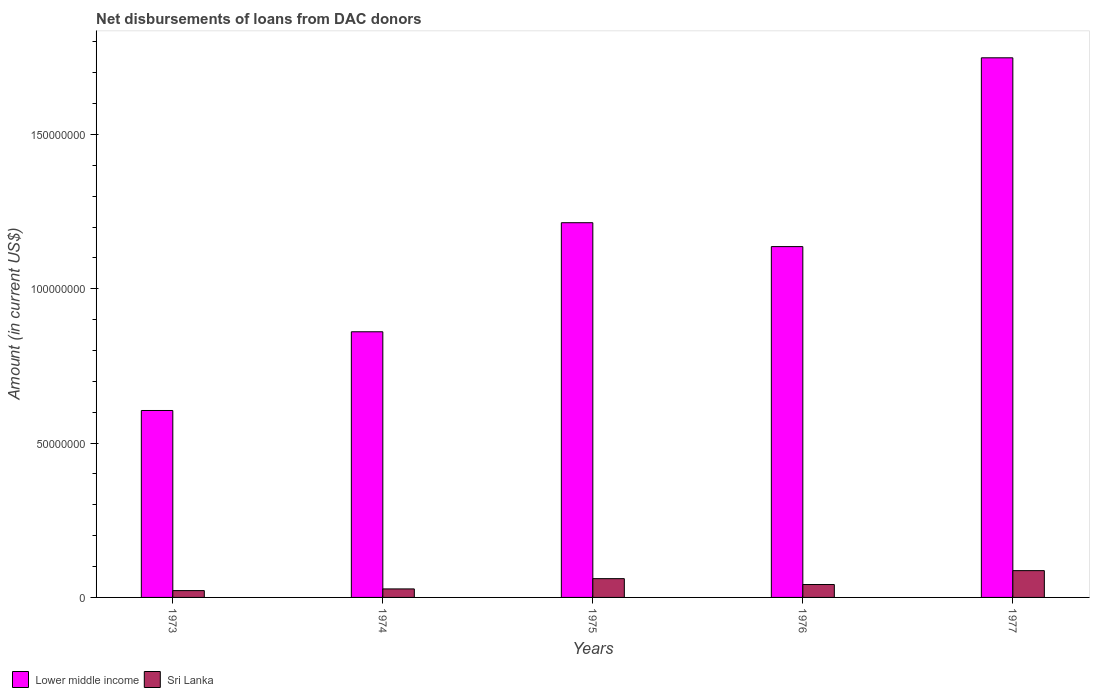Are the number of bars on each tick of the X-axis equal?
Give a very brief answer. Yes. How many bars are there on the 5th tick from the left?
Provide a short and direct response. 2. How many bars are there on the 1st tick from the right?
Make the answer very short. 2. What is the label of the 2nd group of bars from the left?
Ensure brevity in your answer.  1974. In how many cases, is the number of bars for a given year not equal to the number of legend labels?
Your response must be concise. 0. What is the amount of loans disbursed in Lower middle income in 1973?
Provide a short and direct response. 6.06e+07. Across all years, what is the maximum amount of loans disbursed in Lower middle income?
Your response must be concise. 1.75e+08. Across all years, what is the minimum amount of loans disbursed in Sri Lanka?
Provide a short and direct response. 2.21e+06. In which year was the amount of loans disbursed in Lower middle income maximum?
Provide a short and direct response. 1977. In which year was the amount of loans disbursed in Sri Lanka minimum?
Provide a short and direct response. 1973. What is the total amount of loans disbursed in Sri Lanka in the graph?
Offer a very short reply. 2.39e+07. What is the difference between the amount of loans disbursed in Lower middle income in 1976 and that in 1977?
Ensure brevity in your answer.  -6.12e+07. What is the difference between the amount of loans disbursed in Lower middle income in 1977 and the amount of loans disbursed in Sri Lanka in 1976?
Ensure brevity in your answer.  1.71e+08. What is the average amount of loans disbursed in Sri Lanka per year?
Provide a short and direct response. 4.78e+06. In the year 1974, what is the difference between the amount of loans disbursed in Lower middle income and amount of loans disbursed in Sri Lanka?
Your answer should be compact. 8.33e+07. What is the ratio of the amount of loans disbursed in Sri Lanka in 1973 to that in 1976?
Your response must be concise. 0.53. What is the difference between the highest and the second highest amount of loans disbursed in Lower middle income?
Offer a very short reply. 5.34e+07. What is the difference between the highest and the lowest amount of loans disbursed in Sri Lanka?
Your response must be concise. 6.47e+06. Is the sum of the amount of loans disbursed in Lower middle income in 1974 and 1975 greater than the maximum amount of loans disbursed in Sri Lanka across all years?
Keep it short and to the point. Yes. What does the 2nd bar from the left in 1975 represents?
Provide a succinct answer. Sri Lanka. What does the 1st bar from the right in 1977 represents?
Your answer should be compact. Sri Lanka. How many bars are there?
Make the answer very short. 10. How many years are there in the graph?
Offer a very short reply. 5. Does the graph contain grids?
Provide a short and direct response. No. Where does the legend appear in the graph?
Provide a short and direct response. Bottom left. How many legend labels are there?
Your response must be concise. 2. What is the title of the graph?
Your answer should be compact. Net disbursements of loans from DAC donors. What is the label or title of the X-axis?
Your response must be concise. Years. What is the Amount (in current US$) of Lower middle income in 1973?
Your answer should be compact. 6.06e+07. What is the Amount (in current US$) of Sri Lanka in 1973?
Provide a succinct answer. 2.21e+06. What is the Amount (in current US$) of Lower middle income in 1974?
Provide a short and direct response. 8.61e+07. What is the Amount (in current US$) in Sri Lanka in 1974?
Make the answer very short. 2.76e+06. What is the Amount (in current US$) in Lower middle income in 1975?
Keep it short and to the point. 1.21e+08. What is the Amount (in current US$) of Sri Lanka in 1975?
Provide a succinct answer. 6.08e+06. What is the Amount (in current US$) in Lower middle income in 1976?
Ensure brevity in your answer.  1.14e+08. What is the Amount (in current US$) of Sri Lanka in 1976?
Your answer should be very brief. 4.18e+06. What is the Amount (in current US$) in Lower middle income in 1977?
Offer a very short reply. 1.75e+08. What is the Amount (in current US$) in Sri Lanka in 1977?
Make the answer very short. 8.68e+06. Across all years, what is the maximum Amount (in current US$) of Lower middle income?
Give a very brief answer. 1.75e+08. Across all years, what is the maximum Amount (in current US$) in Sri Lanka?
Keep it short and to the point. 8.68e+06. Across all years, what is the minimum Amount (in current US$) of Lower middle income?
Ensure brevity in your answer.  6.06e+07. Across all years, what is the minimum Amount (in current US$) of Sri Lanka?
Provide a succinct answer. 2.21e+06. What is the total Amount (in current US$) of Lower middle income in the graph?
Your response must be concise. 5.56e+08. What is the total Amount (in current US$) in Sri Lanka in the graph?
Make the answer very short. 2.39e+07. What is the difference between the Amount (in current US$) in Lower middle income in 1973 and that in 1974?
Make the answer very short. -2.55e+07. What is the difference between the Amount (in current US$) in Sri Lanka in 1973 and that in 1974?
Keep it short and to the point. -5.48e+05. What is the difference between the Amount (in current US$) in Lower middle income in 1973 and that in 1975?
Your response must be concise. -6.08e+07. What is the difference between the Amount (in current US$) in Sri Lanka in 1973 and that in 1975?
Ensure brevity in your answer.  -3.87e+06. What is the difference between the Amount (in current US$) of Lower middle income in 1973 and that in 1976?
Ensure brevity in your answer.  -5.31e+07. What is the difference between the Amount (in current US$) in Sri Lanka in 1973 and that in 1976?
Ensure brevity in your answer.  -1.97e+06. What is the difference between the Amount (in current US$) of Lower middle income in 1973 and that in 1977?
Make the answer very short. -1.14e+08. What is the difference between the Amount (in current US$) of Sri Lanka in 1973 and that in 1977?
Your answer should be very brief. -6.47e+06. What is the difference between the Amount (in current US$) of Lower middle income in 1974 and that in 1975?
Offer a very short reply. -3.53e+07. What is the difference between the Amount (in current US$) in Sri Lanka in 1974 and that in 1975?
Make the answer very short. -3.32e+06. What is the difference between the Amount (in current US$) of Lower middle income in 1974 and that in 1976?
Provide a short and direct response. -2.76e+07. What is the difference between the Amount (in current US$) of Sri Lanka in 1974 and that in 1976?
Your answer should be compact. -1.42e+06. What is the difference between the Amount (in current US$) of Lower middle income in 1974 and that in 1977?
Your answer should be compact. -8.88e+07. What is the difference between the Amount (in current US$) of Sri Lanka in 1974 and that in 1977?
Make the answer very short. -5.92e+06. What is the difference between the Amount (in current US$) of Lower middle income in 1975 and that in 1976?
Your answer should be compact. 7.74e+06. What is the difference between the Amount (in current US$) in Sri Lanka in 1975 and that in 1976?
Provide a short and direct response. 1.90e+06. What is the difference between the Amount (in current US$) of Lower middle income in 1975 and that in 1977?
Offer a terse response. -5.34e+07. What is the difference between the Amount (in current US$) of Sri Lanka in 1975 and that in 1977?
Make the answer very short. -2.60e+06. What is the difference between the Amount (in current US$) in Lower middle income in 1976 and that in 1977?
Ensure brevity in your answer.  -6.12e+07. What is the difference between the Amount (in current US$) in Sri Lanka in 1976 and that in 1977?
Your response must be concise. -4.50e+06. What is the difference between the Amount (in current US$) of Lower middle income in 1973 and the Amount (in current US$) of Sri Lanka in 1974?
Provide a short and direct response. 5.78e+07. What is the difference between the Amount (in current US$) of Lower middle income in 1973 and the Amount (in current US$) of Sri Lanka in 1975?
Your answer should be very brief. 5.45e+07. What is the difference between the Amount (in current US$) of Lower middle income in 1973 and the Amount (in current US$) of Sri Lanka in 1976?
Make the answer very short. 5.64e+07. What is the difference between the Amount (in current US$) of Lower middle income in 1973 and the Amount (in current US$) of Sri Lanka in 1977?
Offer a terse response. 5.19e+07. What is the difference between the Amount (in current US$) of Lower middle income in 1974 and the Amount (in current US$) of Sri Lanka in 1975?
Your answer should be very brief. 8.00e+07. What is the difference between the Amount (in current US$) in Lower middle income in 1974 and the Amount (in current US$) in Sri Lanka in 1976?
Make the answer very short. 8.19e+07. What is the difference between the Amount (in current US$) of Lower middle income in 1974 and the Amount (in current US$) of Sri Lanka in 1977?
Offer a terse response. 7.74e+07. What is the difference between the Amount (in current US$) of Lower middle income in 1975 and the Amount (in current US$) of Sri Lanka in 1976?
Your response must be concise. 1.17e+08. What is the difference between the Amount (in current US$) of Lower middle income in 1975 and the Amount (in current US$) of Sri Lanka in 1977?
Your answer should be very brief. 1.13e+08. What is the difference between the Amount (in current US$) of Lower middle income in 1976 and the Amount (in current US$) of Sri Lanka in 1977?
Make the answer very short. 1.05e+08. What is the average Amount (in current US$) in Lower middle income per year?
Offer a terse response. 1.11e+08. What is the average Amount (in current US$) of Sri Lanka per year?
Give a very brief answer. 4.78e+06. In the year 1973, what is the difference between the Amount (in current US$) in Lower middle income and Amount (in current US$) in Sri Lanka?
Give a very brief answer. 5.83e+07. In the year 1974, what is the difference between the Amount (in current US$) of Lower middle income and Amount (in current US$) of Sri Lanka?
Give a very brief answer. 8.33e+07. In the year 1975, what is the difference between the Amount (in current US$) in Lower middle income and Amount (in current US$) in Sri Lanka?
Provide a short and direct response. 1.15e+08. In the year 1976, what is the difference between the Amount (in current US$) of Lower middle income and Amount (in current US$) of Sri Lanka?
Provide a short and direct response. 1.09e+08. In the year 1977, what is the difference between the Amount (in current US$) of Lower middle income and Amount (in current US$) of Sri Lanka?
Offer a terse response. 1.66e+08. What is the ratio of the Amount (in current US$) in Lower middle income in 1973 to that in 1974?
Your answer should be compact. 0.7. What is the ratio of the Amount (in current US$) of Sri Lanka in 1973 to that in 1974?
Provide a short and direct response. 0.8. What is the ratio of the Amount (in current US$) in Lower middle income in 1973 to that in 1975?
Keep it short and to the point. 0.5. What is the ratio of the Amount (in current US$) of Sri Lanka in 1973 to that in 1975?
Keep it short and to the point. 0.36. What is the ratio of the Amount (in current US$) in Lower middle income in 1973 to that in 1976?
Offer a very short reply. 0.53. What is the ratio of the Amount (in current US$) of Sri Lanka in 1973 to that in 1976?
Provide a short and direct response. 0.53. What is the ratio of the Amount (in current US$) in Lower middle income in 1973 to that in 1977?
Provide a short and direct response. 0.35. What is the ratio of the Amount (in current US$) in Sri Lanka in 1973 to that in 1977?
Provide a succinct answer. 0.25. What is the ratio of the Amount (in current US$) of Lower middle income in 1974 to that in 1975?
Offer a terse response. 0.71. What is the ratio of the Amount (in current US$) in Sri Lanka in 1974 to that in 1975?
Give a very brief answer. 0.45. What is the ratio of the Amount (in current US$) in Lower middle income in 1974 to that in 1976?
Keep it short and to the point. 0.76. What is the ratio of the Amount (in current US$) in Sri Lanka in 1974 to that in 1976?
Your answer should be very brief. 0.66. What is the ratio of the Amount (in current US$) in Lower middle income in 1974 to that in 1977?
Keep it short and to the point. 0.49. What is the ratio of the Amount (in current US$) in Sri Lanka in 1974 to that in 1977?
Offer a terse response. 0.32. What is the ratio of the Amount (in current US$) of Lower middle income in 1975 to that in 1976?
Your answer should be very brief. 1.07. What is the ratio of the Amount (in current US$) of Sri Lanka in 1975 to that in 1976?
Your answer should be compact. 1.46. What is the ratio of the Amount (in current US$) of Lower middle income in 1975 to that in 1977?
Keep it short and to the point. 0.69. What is the ratio of the Amount (in current US$) of Sri Lanka in 1975 to that in 1977?
Make the answer very short. 0.7. What is the ratio of the Amount (in current US$) in Lower middle income in 1976 to that in 1977?
Keep it short and to the point. 0.65. What is the ratio of the Amount (in current US$) of Sri Lanka in 1976 to that in 1977?
Ensure brevity in your answer.  0.48. What is the difference between the highest and the second highest Amount (in current US$) of Lower middle income?
Offer a terse response. 5.34e+07. What is the difference between the highest and the second highest Amount (in current US$) in Sri Lanka?
Provide a short and direct response. 2.60e+06. What is the difference between the highest and the lowest Amount (in current US$) of Lower middle income?
Offer a very short reply. 1.14e+08. What is the difference between the highest and the lowest Amount (in current US$) in Sri Lanka?
Ensure brevity in your answer.  6.47e+06. 